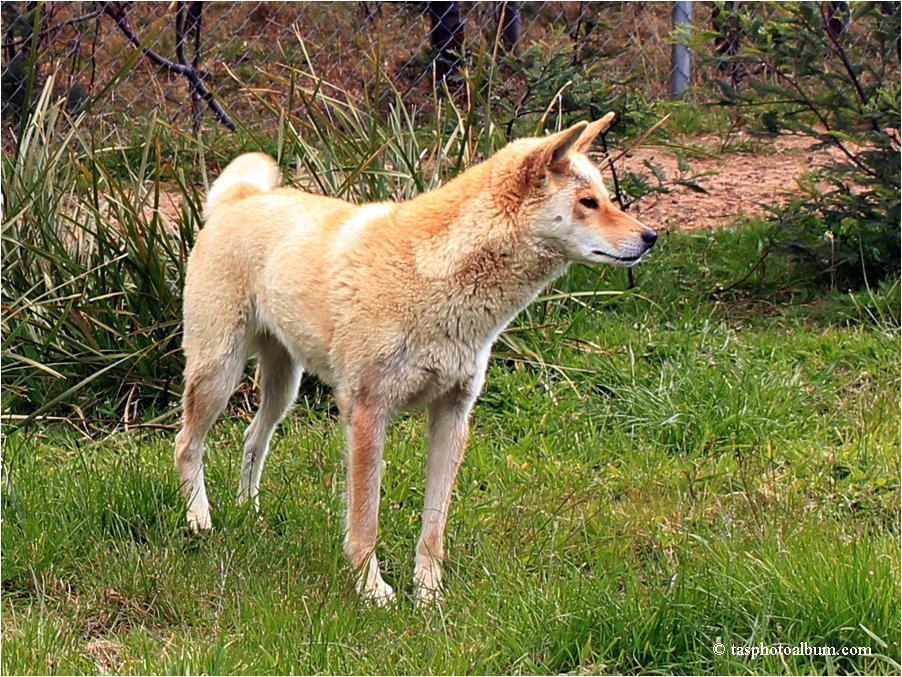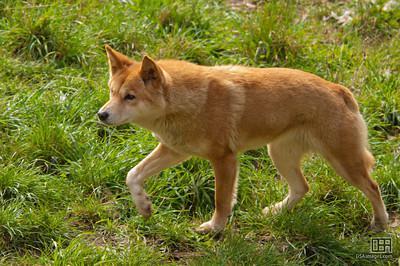The first image is the image on the left, the second image is the image on the right. Assess this claim about the two images: "All dogs in the images are standing with all visible paws on the ground.". Correct or not? Answer yes or no. No. 